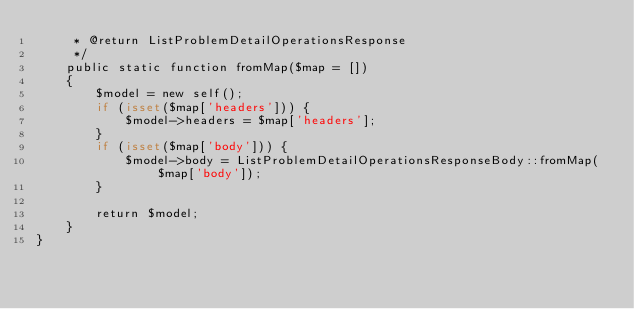Convert code to text. <code><loc_0><loc_0><loc_500><loc_500><_PHP_>     * @return ListProblemDetailOperationsResponse
     */
    public static function fromMap($map = [])
    {
        $model = new self();
        if (isset($map['headers'])) {
            $model->headers = $map['headers'];
        }
        if (isset($map['body'])) {
            $model->body = ListProblemDetailOperationsResponseBody::fromMap($map['body']);
        }

        return $model;
    }
}
</code> 